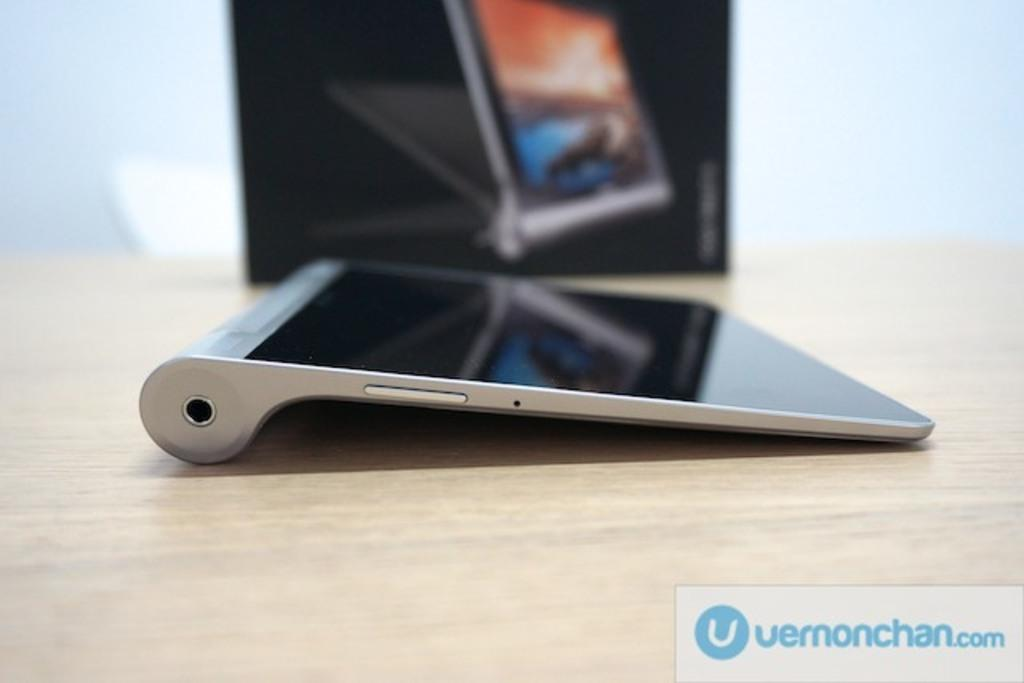<image>
Share a concise interpretation of the image provided. a touch screen device with the logo for vermonchan.com 